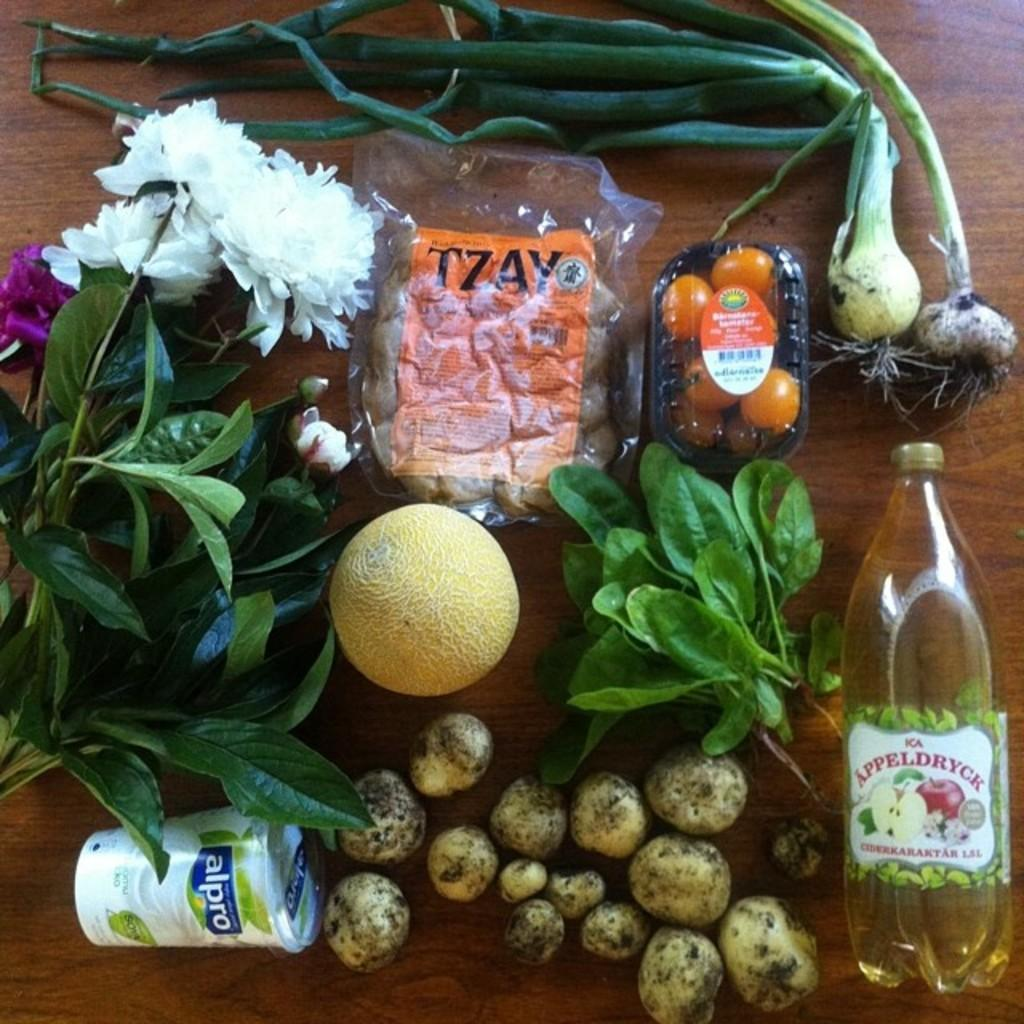What types of food items can be seen on the table in the image? There are vegetables and fruits on the table in the image. Are there any condiments or cooking ingredients on the table? Yes, there are bottles of oil on the table. How many men are transporting the stew in the image? There is no stew or men present in the image; it only features vegetables, fruits, and bottles of oil on a table. 